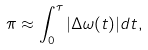Convert formula to latex. <formula><loc_0><loc_0><loc_500><loc_500>\pi \approx \int _ { 0 } ^ { \tau } | \Delta \omega ( t ) | d t ,</formula> 